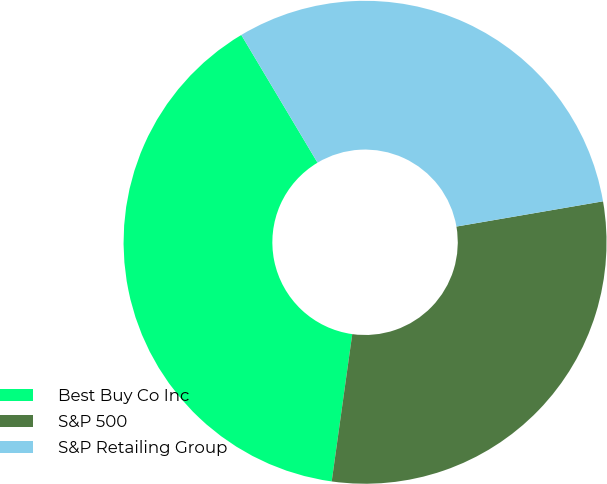<chart> <loc_0><loc_0><loc_500><loc_500><pie_chart><fcel>Best Buy Co Inc<fcel>S&P 500<fcel>S&P Retailing Group<nl><fcel>39.23%<fcel>29.92%<fcel>30.85%<nl></chart> 